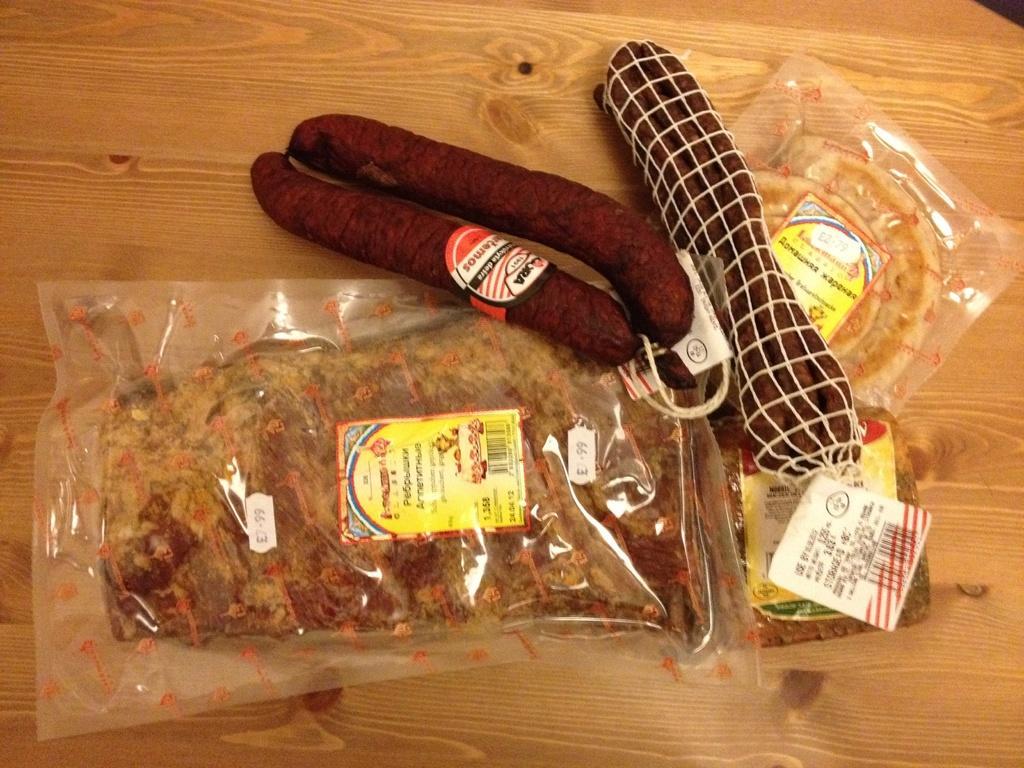How would you summarize this image in a sentence or two? In this image I can see sausages, food packets and covers kept on the table. This image is taken in a room. 